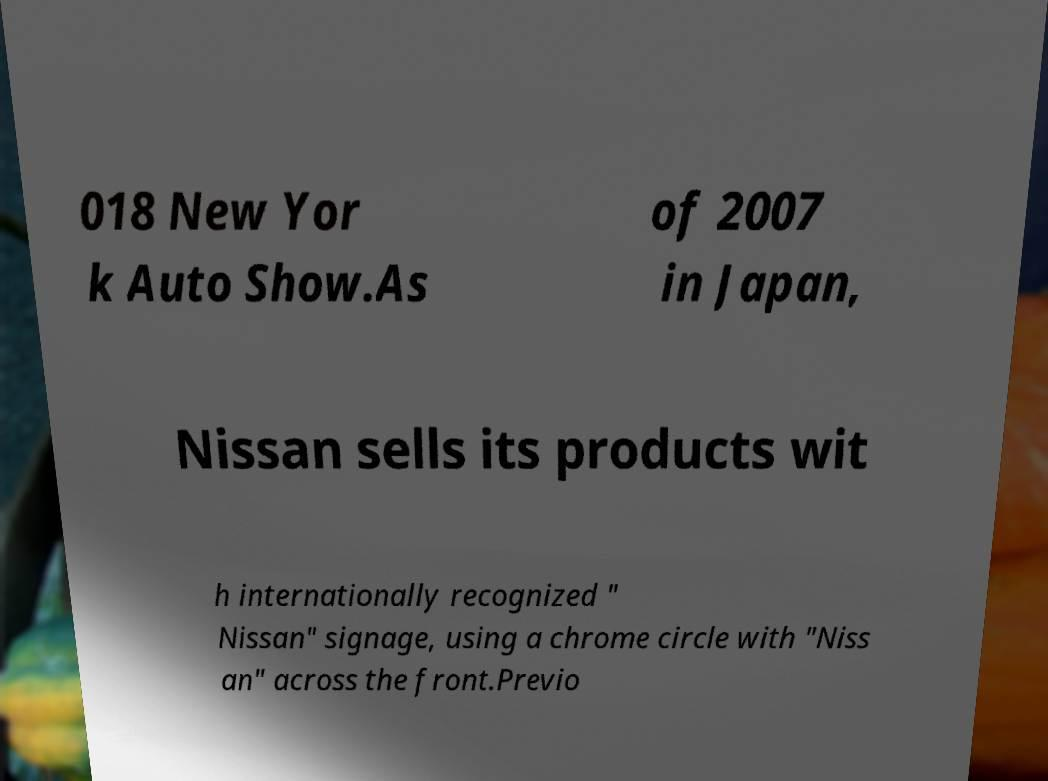What messages or text are displayed in this image? I need them in a readable, typed format. 018 New Yor k Auto Show.As of 2007 in Japan, Nissan sells its products wit h internationally recognized " Nissan" signage, using a chrome circle with "Niss an" across the front.Previo 